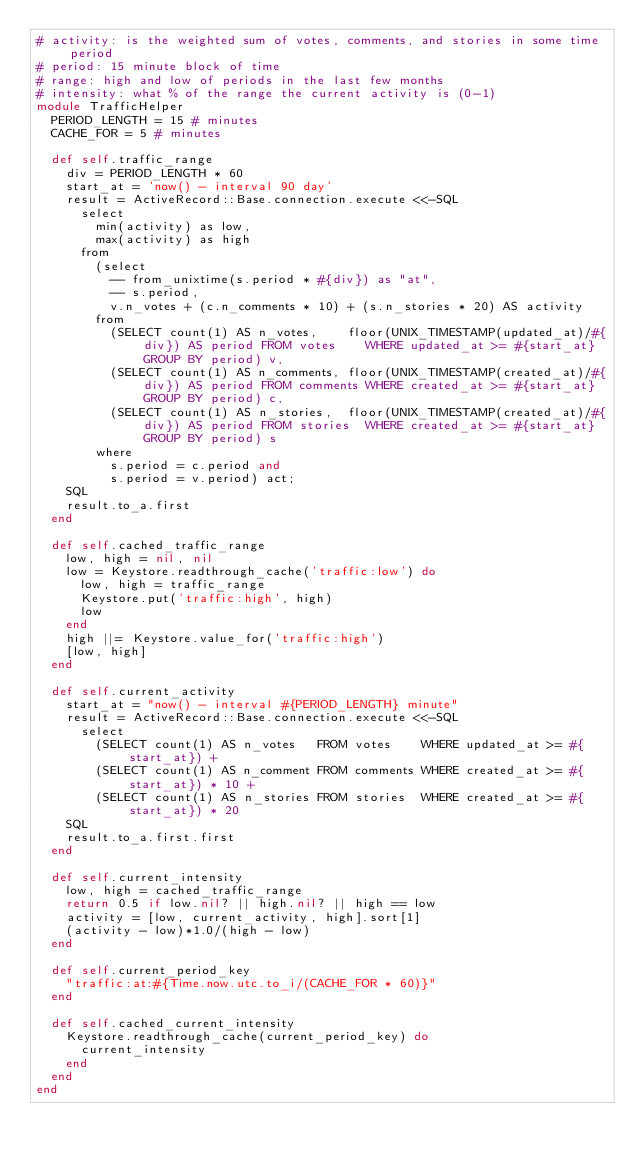Convert code to text. <code><loc_0><loc_0><loc_500><loc_500><_Ruby_># activity: is the weighted sum of votes, comments, and stories in some time period
# period: 15 minute block of time
# range: high and low of periods in the last few months
# intensity: what % of the range the current activity is (0-1)
module TrafficHelper
  PERIOD_LENGTH = 15 # minutes
  CACHE_FOR = 5 # minutes

  def self.traffic_range
    div = PERIOD_LENGTH * 60
    start_at = 'now() - interval 90 day'
    result = ActiveRecord::Base.connection.execute <<-SQL
      select
        min(activity) as low,
        max(activity) as high
      from
        (select
          -- from_unixtime(s.period * #{div}) as "at",
          -- s.period,
          v.n_votes + (c.n_comments * 10) + (s.n_stories * 20) AS activity
        from
          (SELECT count(1) AS n_votes,    floor(UNIX_TIMESTAMP(updated_at)/#{div}) AS period FROM votes    WHERE updated_at >= #{start_at} GROUP BY period) v,
          (SELECT count(1) AS n_comments, floor(UNIX_TIMESTAMP(created_at)/#{div}) AS period FROM comments WHERE created_at >= #{start_at} GROUP BY period) c,
          (SELECT count(1) AS n_stories,  floor(UNIX_TIMESTAMP(created_at)/#{div}) AS period FROM stories  WHERE created_at >= #{start_at} GROUP BY period) s
        where
          s.period = c.period and
          s.period = v.period) act;
    SQL
    result.to_a.first
  end

  def self.cached_traffic_range
    low, high = nil, nil
    low = Keystore.readthrough_cache('traffic:low') do
      low, high = traffic_range
      Keystore.put('traffic:high', high)
      low
    end
    high ||= Keystore.value_for('traffic:high')
    [low, high]
  end

  def self.current_activity
    start_at = "now() - interval #{PERIOD_LENGTH} minute"
    result = ActiveRecord::Base.connection.execute <<-SQL
      select
        (SELECT count(1) AS n_votes   FROM votes    WHERE updated_at >= #{start_at}) +
        (SELECT count(1) AS n_comment FROM comments WHERE created_at >= #{start_at}) * 10 +
        (SELECT count(1) AS n_stories FROM stories  WHERE created_at >= #{start_at}) * 20
    SQL
    result.to_a.first.first
  end

  def self.current_intensity
    low, high = cached_traffic_range
    return 0.5 if low.nil? || high.nil? || high == low
    activity = [low, current_activity, high].sort[1]
    (activity - low)*1.0/(high - low)
  end

  def self.current_period_key
    "traffic:at:#{Time.now.utc.to_i/(CACHE_FOR * 60)}"
  end

  def self.cached_current_intensity
    Keystore.readthrough_cache(current_period_key) do
      current_intensity
    end
  end
end
</code> 